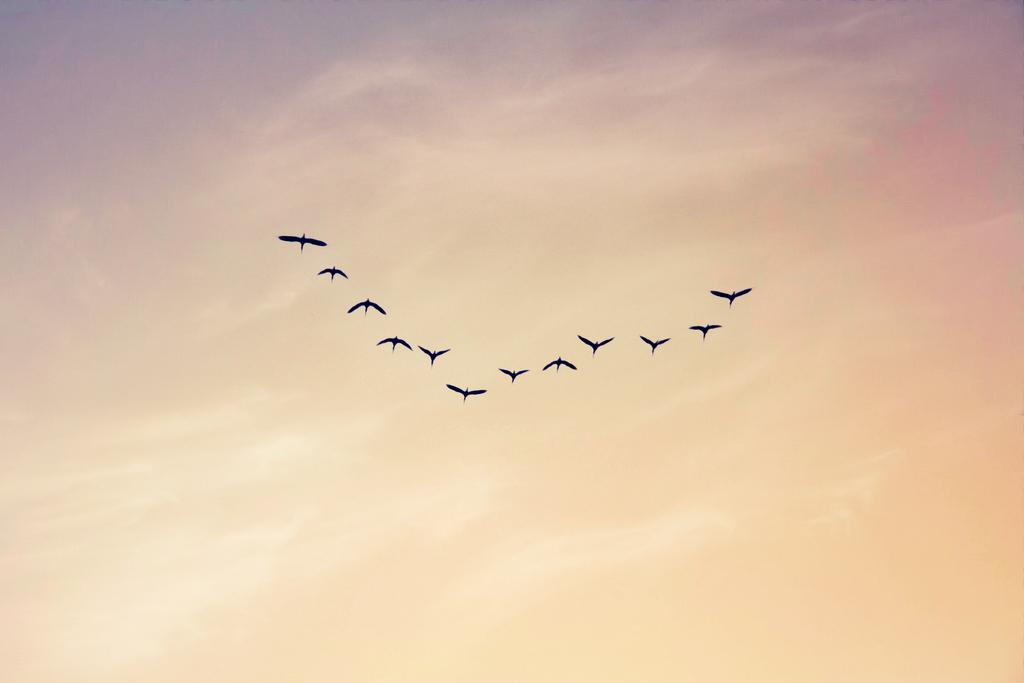What is happening in the image involving animals? There are birds flying in the image. Where are the birds located? The birds are in the sky. What can be seen in the background of the image? The sky is visible in the image. What is the color of the sky in the image? The sky has a yellow color. Can you tell me how many teeth the mother has in the image? There is no mother or teeth present in the image; it features birds flying in a yellow sky. 